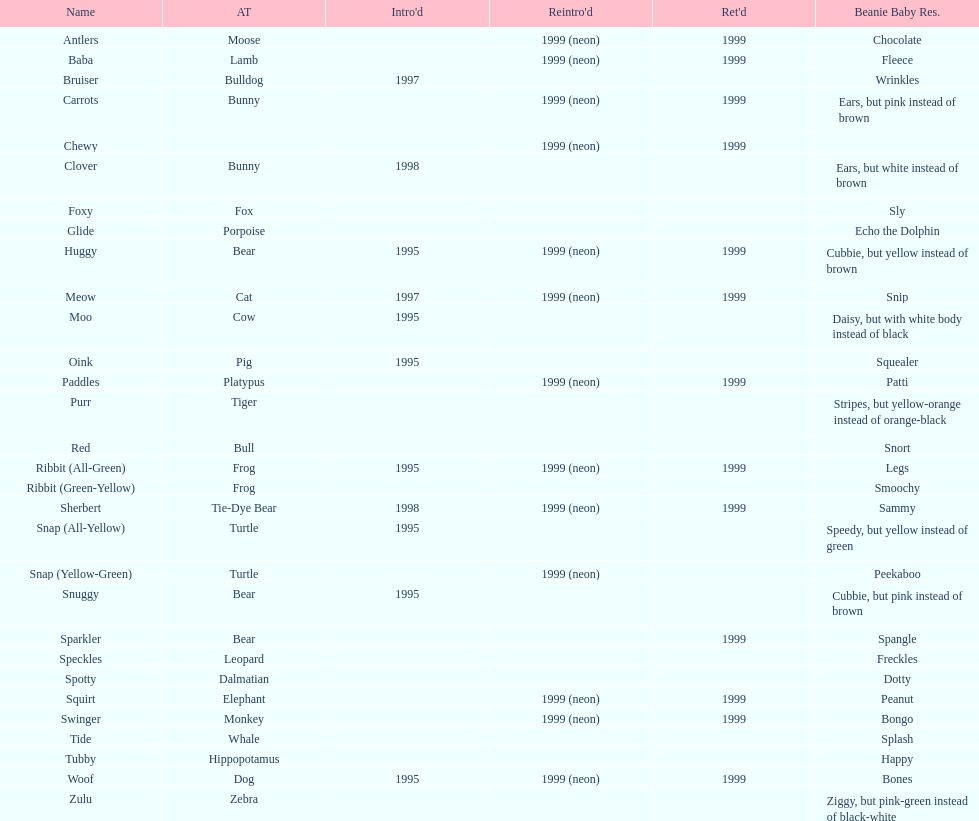What are the total number of pillow pals on this chart? 30. 